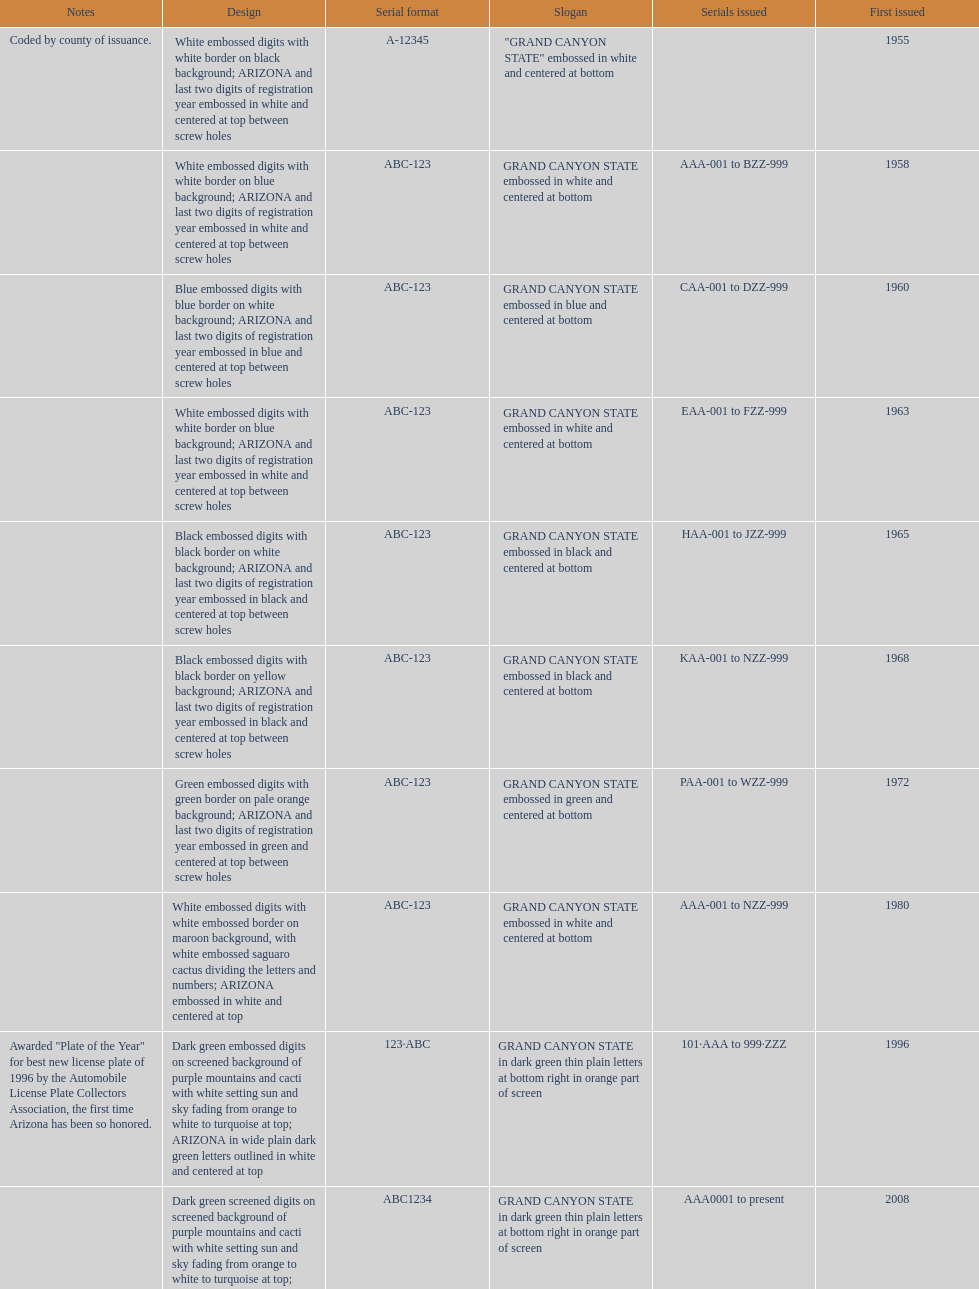What is the average serial format of the arizona license plates? ABC-123. Would you be able to parse every entry in this table? {'header': ['Notes', 'Design', 'Serial format', 'Slogan', 'Serials issued', 'First issued'], 'rows': [['Coded by county of issuance.', 'White embossed digits with white border on black background; ARIZONA and last two digits of registration year embossed in white and centered at top between screw holes', 'A-12345', '"GRAND CANYON STATE" embossed in white and centered at bottom', '', '1955'], ['', 'White embossed digits with white border on blue background; ARIZONA and last two digits of registration year embossed in white and centered at top between screw holes', 'ABC-123', 'GRAND CANYON STATE embossed in white and centered at bottom', 'AAA-001 to BZZ-999', '1958'], ['', 'Blue embossed digits with blue border on white background; ARIZONA and last two digits of registration year embossed in blue and centered at top between screw holes', 'ABC-123', 'GRAND CANYON STATE embossed in blue and centered at bottom', 'CAA-001 to DZZ-999', '1960'], ['', 'White embossed digits with white border on blue background; ARIZONA and last two digits of registration year embossed in white and centered at top between screw holes', 'ABC-123', 'GRAND CANYON STATE embossed in white and centered at bottom', 'EAA-001 to FZZ-999', '1963'], ['', 'Black embossed digits with black border on white background; ARIZONA and last two digits of registration year embossed in black and centered at top between screw holes', 'ABC-123', 'GRAND CANYON STATE embossed in black and centered at bottom', 'HAA-001 to JZZ-999', '1965'], ['', 'Black embossed digits with black border on yellow background; ARIZONA and last two digits of registration year embossed in black and centered at top between screw holes', 'ABC-123', 'GRAND CANYON STATE embossed in black and centered at bottom', 'KAA-001 to NZZ-999', '1968'], ['', 'Green embossed digits with green border on pale orange background; ARIZONA and last two digits of registration year embossed in green and centered at top between screw holes', 'ABC-123', 'GRAND CANYON STATE embossed in green and centered at bottom', 'PAA-001 to WZZ-999', '1972'], ['', 'White embossed digits with white embossed border on maroon background, with white embossed saguaro cactus dividing the letters and numbers; ARIZONA embossed in white and centered at top', 'ABC-123', 'GRAND CANYON STATE embossed in white and centered at bottom', 'AAA-001 to NZZ-999', '1980'], ['Awarded "Plate of the Year" for best new license plate of 1996 by the Automobile License Plate Collectors Association, the first time Arizona has been so honored.', 'Dark green embossed digits on screened background of purple mountains and cacti with white setting sun and sky fading from orange to white to turquoise at top; ARIZONA in wide plain dark green letters outlined in white and centered at top', '123·ABC', 'GRAND CANYON STATE in dark green thin plain letters at bottom right in orange part of screen', '101·AAA to 999·ZZZ', '1996'], ['', 'Dark green screened digits on screened background of purple mountains and cacti with white setting sun and sky fading from orange to white to turquoise at top; ARIZONA in wide plain dark green letters outlined in white and centered at top; security stripe through center of plate', 'ABC1234', 'GRAND CANYON STATE in dark green thin plain letters at bottom right in orange part of screen', 'AAA0001 to present', '2008']]} 